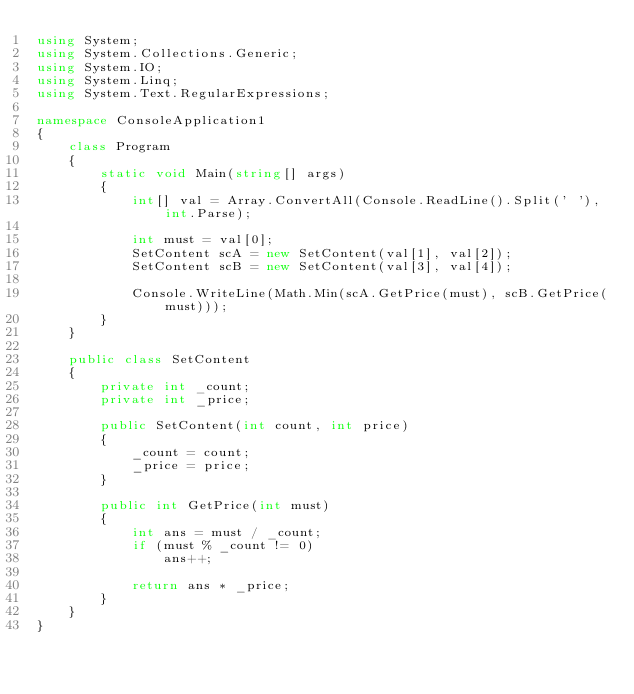Convert code to text. <code><loc_0><loc_0><loc_500><loc_500><_C#_>using System;
using System.Collections.Generic;
using System.IO;
using System.Linq;
using System.Text.RegularExpressions;

namespace ConsoleApplication1
{
    class Program
    {
        static void Main(string[] args)
        {
            int[] val = Array.ConvertAll(Console.ReadLine().Split(' '), int.Parse);

            int must = val[0];
            SetContent scA = new SetContent(val[1], val[2]);
            SetContent scB = new SetContent(val[3], val[4]);

            Console.WriteLine(Math.Min(scA.GetPrice(must), scB.GetPrice(must)));
        }
    }

    public class SetContent
    {
        private int _count;
        private int _price;

        public SetContent(int count, int price)
        {
            _count = count;
            _price = price;
        }

        public int GetPrice(int must)
        {
            int ans = must / _count;
            if (must % _count != 0)
                ans++;

            return ans * _price;
        }
    }
}
</code> 